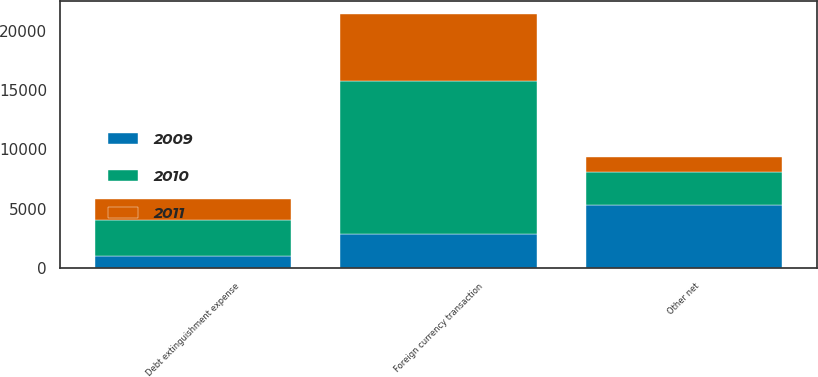Convert chart. <chart><loc_0><loc_0><loc_500><loc_500><stacked_bar_chart><ecel><fcel>Foreign currency transaction<fcel>Debt extinguishment expense<fcel>Other net<nl><fcel>2010<fcel>12845<fcel>3031<fcel>2785<nl><fcel>2011<fcel>5664<fcel>1792<fcel>1312<nl><fcel>2009<fcel>2908<fcel>993<fcel>5302<nl></chart> 